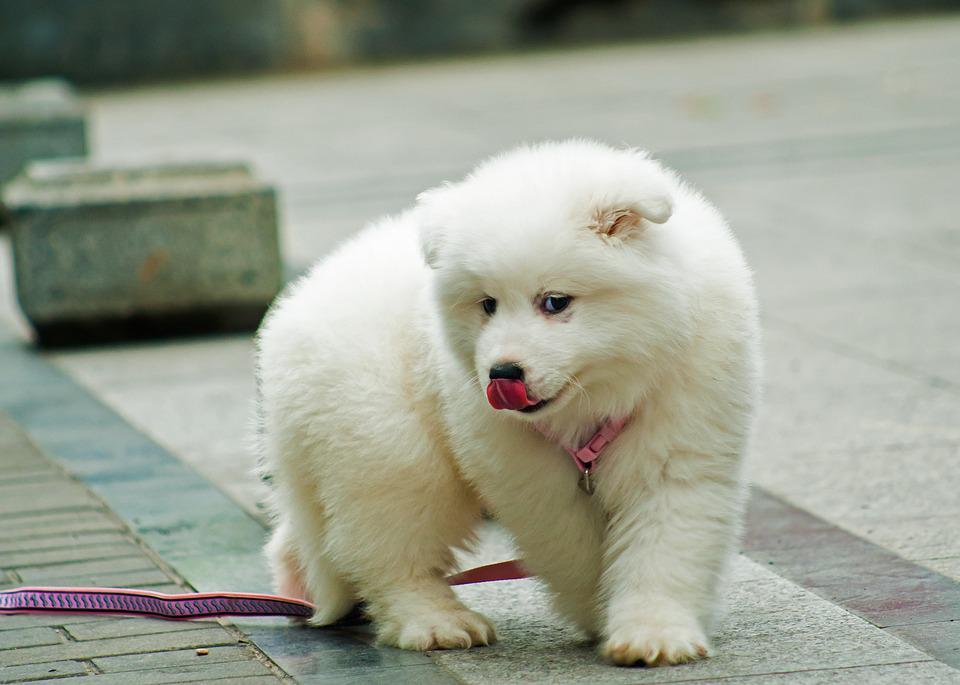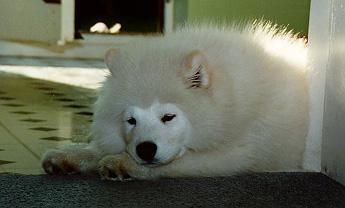The first image is the image on the left, the second image is the image on the right. Evaluate the accuracy of this statement regarding the images: "Both white dogs have their tongues hanging out of their mouths.". Is it true? Answer yes or no. No. The first image is the image on the left, the second image is the image on the right. Assess this claim about the two images: "in the left pic the dog is in a form of grass". Correct or not? Answer yes or no. No. 